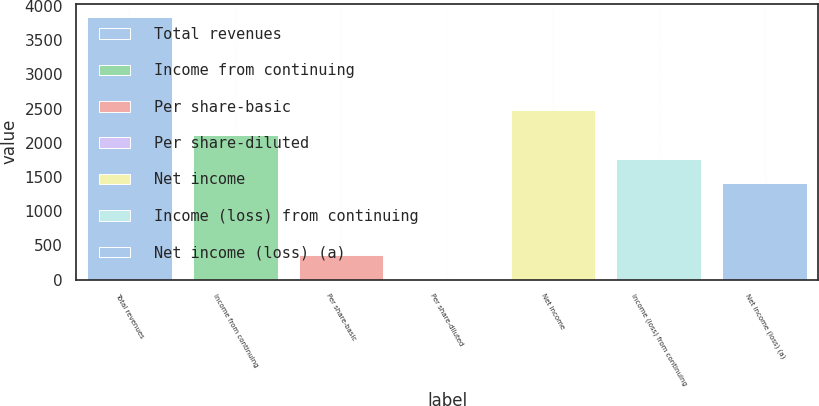Convert chart to OTSL. <chart><loc_0><loc_0><loc_500><loc_500><bar_chart><fcel>Total revenues<fcel>Income from continuing<fcel>Per share-basic<fcel>Per share-diluted<fcel>Net income<fcel>Income (loss) from continuing<fcel>Net income (loss) (a)<nl><fcel>3839.32<fcel>2120.7<fcel>354.1<fcel>0.78<fcel>2474.02<fcel>1767.38<fcel>1414.06<nl></chart> 